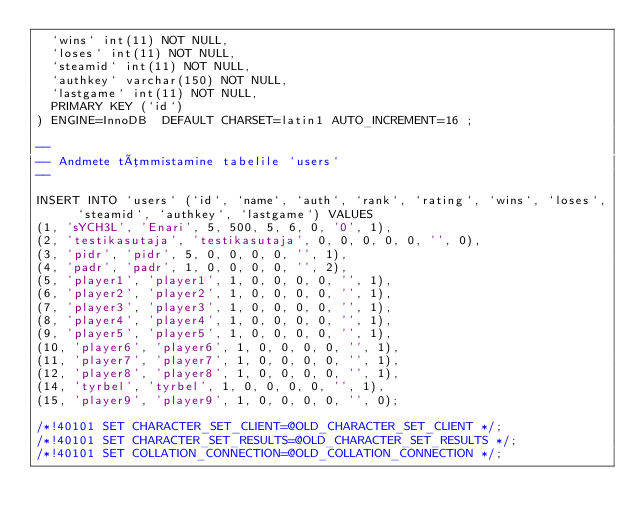<code> <loc_0><loc_0><loc_500><loc_500><_SQL_>  `wins` int(11) NOT NULL,
  `loses` int(11) NOT NULL,
  `steamid` int(11) NOT NULL,
  `authkey` varchar(150) NOT NULL,
  `lastgame` int(11) NOT NULL,
  PRIMARY KEY (`id`)
) ENGINE=InnoDB  DEFAULT CHARSET=latin1 AUTO_INCREMENT=16 ;

--
-- Andmete tõmmistamine tabelile `users`
--

INSERT INTO `users` (`id`, `name`, `auth`, `rank`, `rating`, `wins`, `loses`, `steamid`, `authkey`, `lastgame`) VALUES
(1, 'sYCH3L', 'Enari', 5, 500, 5, 6, 0, '0', 1),
(2, 'testikasutaja', 'testikasutaja', 0, 0, 0, 0, 0, '', 0),
(3, 'pidr', 'pidr', 5, 0, 0, 0, 0, '', 1),
(4, 'padr', 'padr', 1, 0, 0, 0, 0, '', 2),
(5, 'player1', 'player1', 1, 0, 0, 0, 0, '', 1),
(6, 'player2', 'player2', 1, 0, 0, 0, 0, '', 1),
(7, 'player3', 'player3', 1, 0, 0, 0, 0, '', 1),
(8, 'player4', 'player4', 1, 0, 0, 0, 0, '', 1),
(9, 'player5', 'player5', 1, 0, 0, 0, 0, '', 1),
(10, 'player6', 'player6', 1, 0, 0, 0, 0, '', 1),
(11, 'player7', 'player7', 1, 0, 0, 0, 0, '', 1),
(12, 'player8', 'player8', 1, 0, 0, 0, 0, '', 1),
(14, 'tyrbel', 'tyrbel', 1, 0, 0, 0, 0, '', 1),
(15, 'player9', 'player9', 1, 0, 0, 0, 0, '', 0);

/*!40101 SET CHARACTER_SET_CLIENT=@OLD_CHARACTER_SET_CLIENT */;
/*!40101 SET CHARACTER_SET_RESULTS=@OLD_CHARACTER_SET_RESULTS */;
/*!40101 SET COLLATION_CONNECTION=@OLD_COLLATION_CONNECTION */;
</code> 